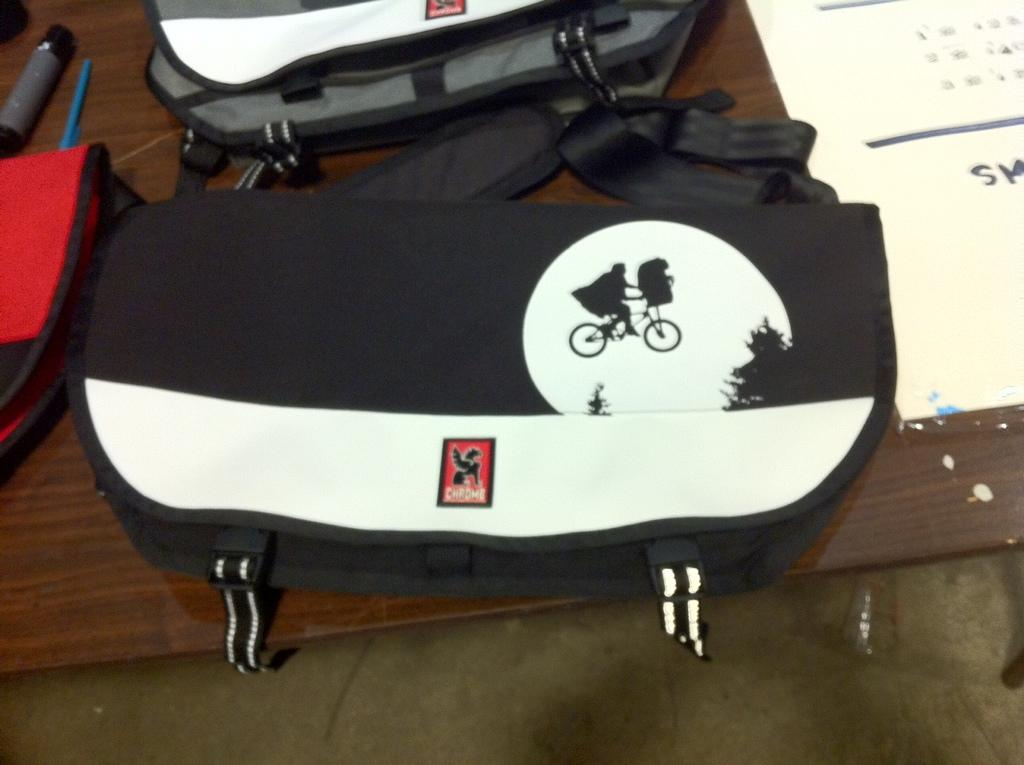What items can be seen on the table in the image? There are bags and paper on the table. Are there any other objects on the table? Yes, there are unspecified objects on the table. Where is the table located in the image? The table is on the floor. Is there a cobweb hanging from the ceiling in the image? There is no mention of a cobweb in the provided facts, so we cannot determine if one is present in the image. How much change is on the table in the image? There is no mention of change in the provided facts, so we cannot determine if any is present in the image. 